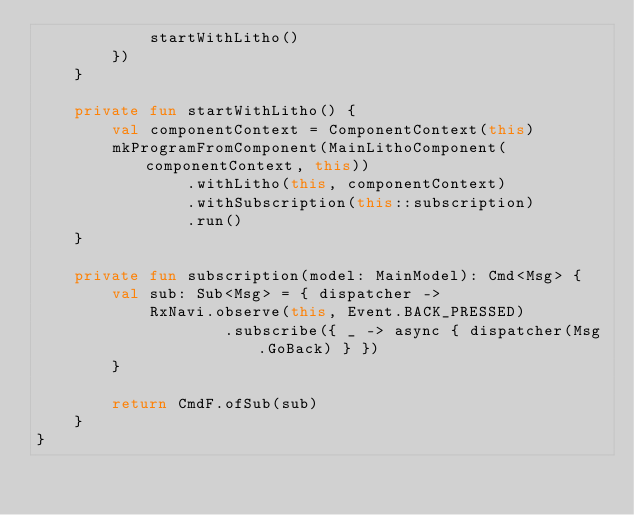Convert code to text. <code><loc_0><loc_0><loc_500><loc_500><_Kotlin_>            startWithLitho()
        })
    }

    private fun startWithLitho() {
        val componentContext = ComponentContext(this)
        mkProgramFromComponent(MainLithoComponent(componentContext, this))
                .withLitho(this, componentContext)
                .withSubscription(this::subscription)
                .run()
    }

    private fun subscription(model: MainModel): Cmd<Msg> {
        val sub: Sub<Msg> = { dispatcher ->
            RxNavi.observe(this, Event.BACK_PRESSED)
                    .subscribe({ _ -> async { dispatcher(Msg.GoBack) } })
        }

        return CmdF.ofSub(sub)
    }
}


</code> 